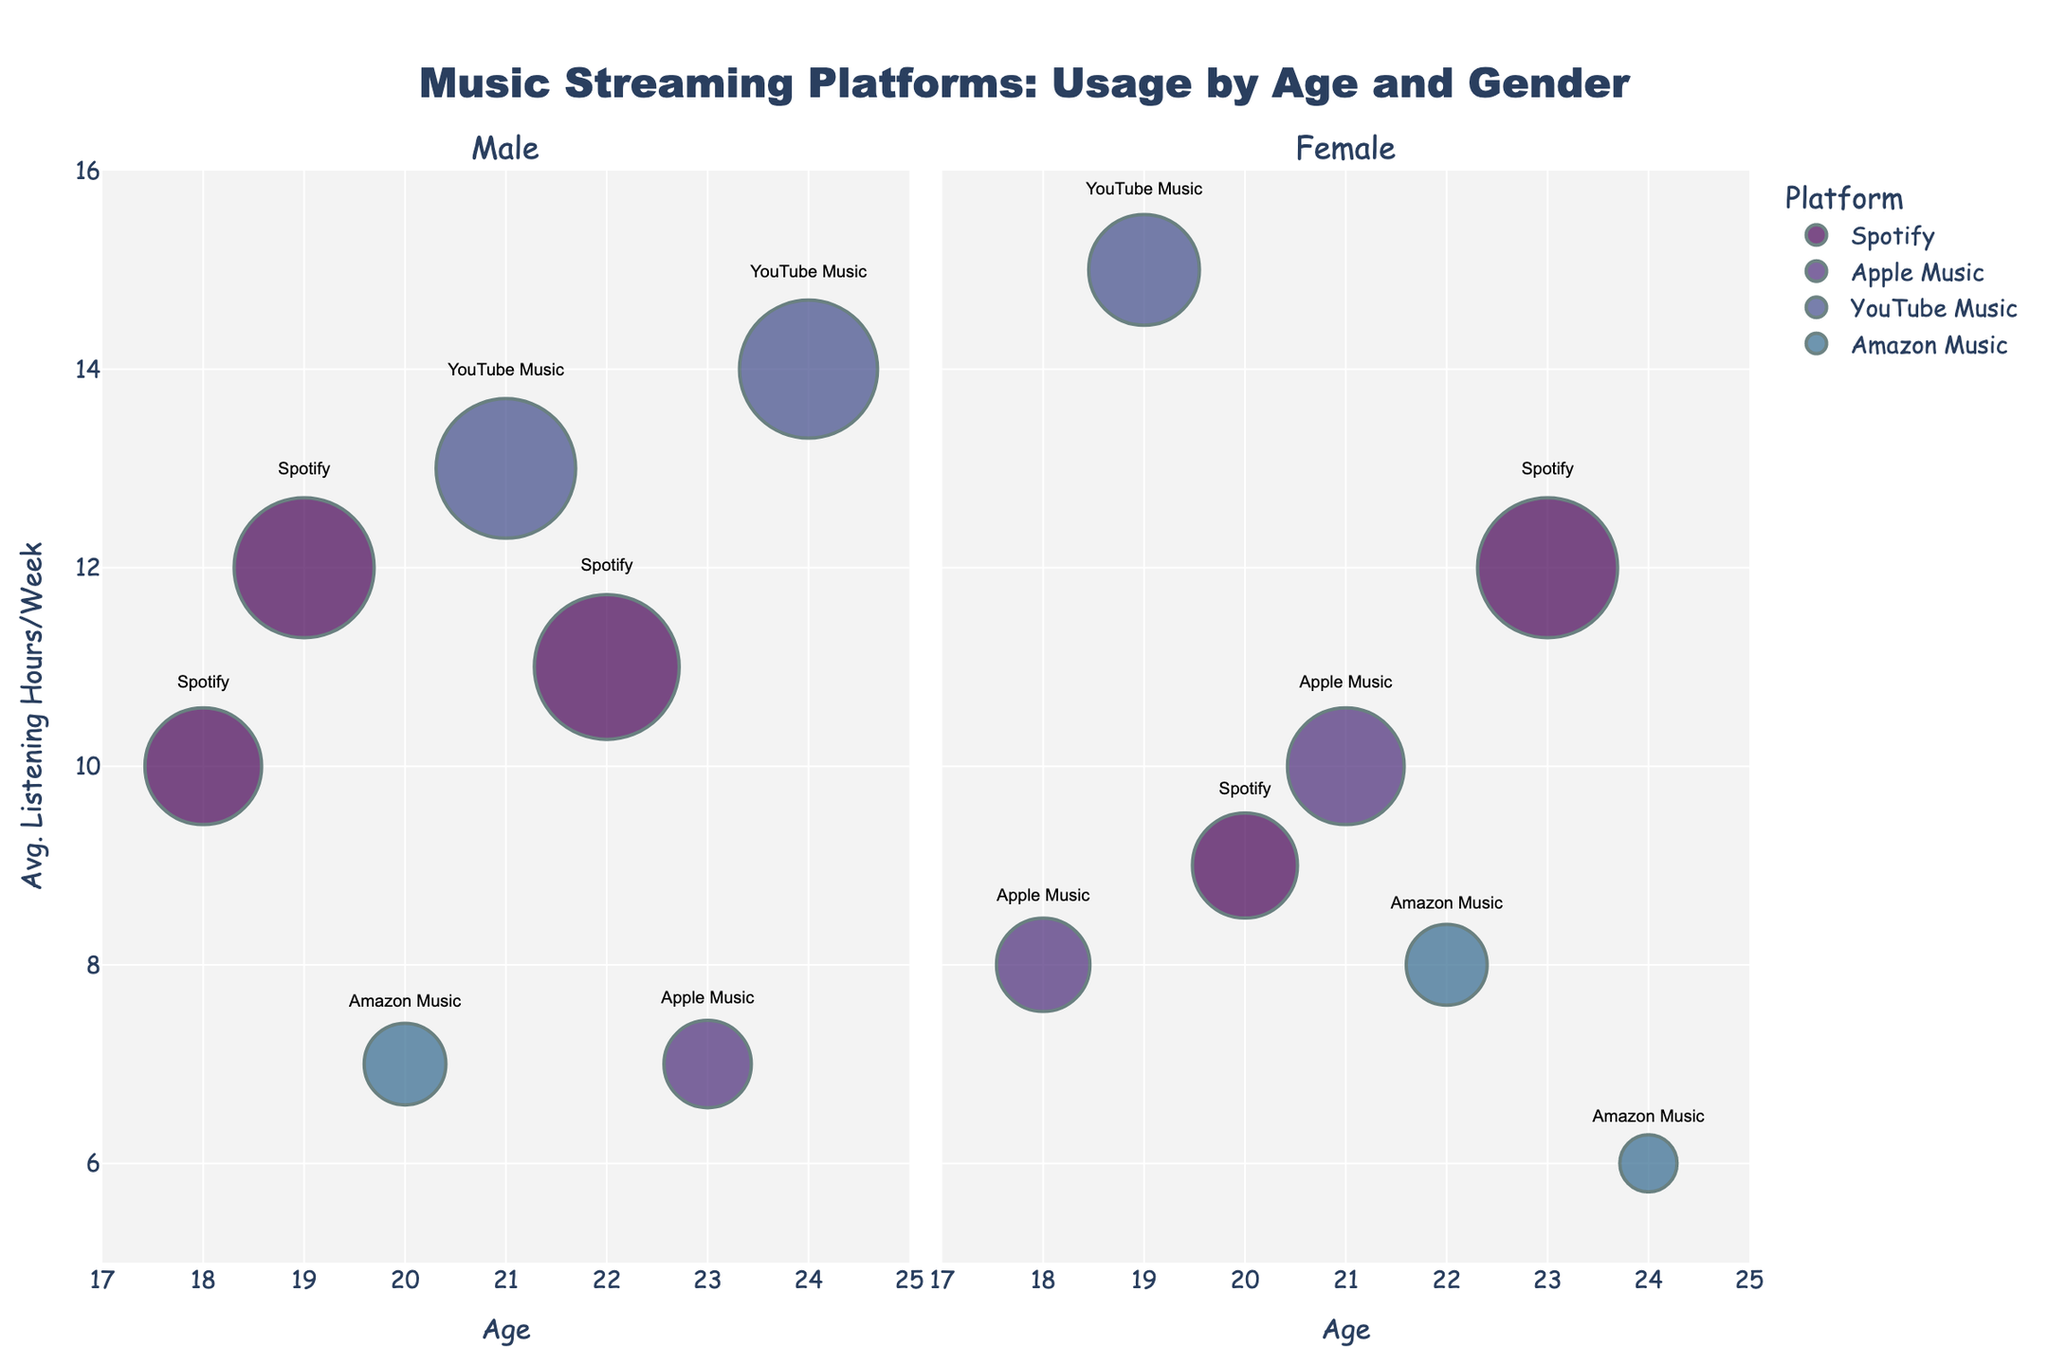What's the title of the figure? The title of the figure is clearly shown at the top of the chart.
Answer: Music Streaming Platforms: Usage by Age and Gender How many platforms are represented in the figure? You can identify the platforms by looking at the colored bubbles and their labels. Count the unique labels.
Answer: 4 Which platform has the largest bubble size for males? By observing the size of the bubbles in the male section, the largest bubble corresponds to the "Spotify" platform at age 19.
Answer: Spotify What is the average listening hours per week for 23-year-old females? Locate the data points for 23-year-old females and identify the recorded average listening hours per week.
Answer: 12 Which gender has a higher average listening hours per week for YouTube Music at age 21? Compare the average listening hours per week for YouTube Music at age 21 for both genders. Males have 13 hours.
Answer: Male What is the average number of listening hours per week for 18-year-olds across all platforms? Calculate the average by summing the listening hours for all 18-year-olds and dividing by the number of 18-year-old data points (10 + 8) / 2.
Answer: 9 Which age group has the most diverse platform usage? Identify the age group with the greatest variety of platforms. Look for different platform labels within the same age group.
Answer: 24 Does Apple Music or Amazon Music have a higher average listening hours per week for females? Compare the average listening hours per week from all female data points for Apple Music and Amazon Music, then find the highest average.
Answer: Apple Music What platform do most 20-year-old males prefer? Identify the platform with the highest number of users for 20-year-old males.
Answer: Amazon Music How does the average listening hours per week for Spotify change from age 18 to age 22 for males? Observe the data points for males using Spotify at ages 18, 19, and 22, and note the change in average listening hours per week.
Answer: Increases 